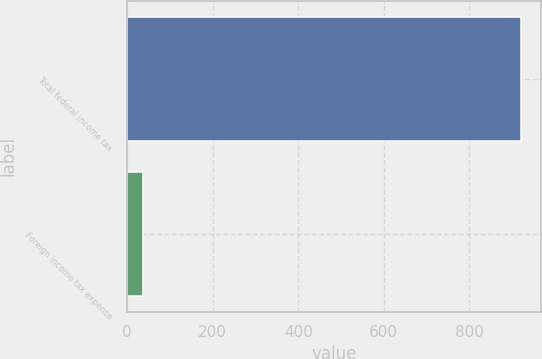Convert chart. <chart><loc_0><loc_0><loc_500><loc_500><bar_chart><fcel>Total federal income tax<fcel>Foreign income tax expense<nl><fcel>921<fcel>38<nl></chart> 